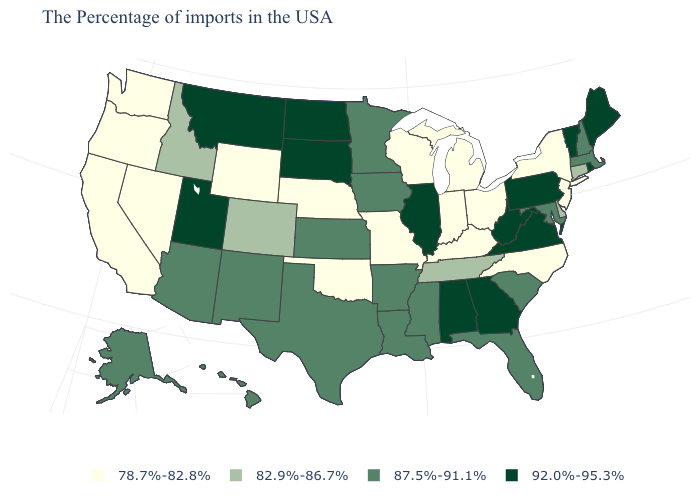What is the value of North Dakota?
Keep it brief. 92.0%-95.3%. What is the highest value in the USA?
Be succinct. 92.0%-95.3%. Does the first symbol in the legend represent the smallest category?
Give a very brief answer. Yes. Among the states that border Rhode Island , which have the highest value?
Keep it brief. Massachusetts. Among the states that border Rhode Island , which have the lowest value?
Answer briefly. Connecticut. What is the highest value in states that border Ohio?
Write a very short answer. 92.0%-95.3%. What is the lowest value in the MidWest?
Write a very short answer. 78.7%-82.8%. Name the states that have a value in the range 78.7%-82.8%?
Answer briefly. New York, New Jersey, North Carolina, Ohio, Michigan, Kentucky, Indiana, Wisconsin, Missouri, Nebraska, Oklahoma, Wyoming, Nevada, California, Washington, Oregon. Which states have the highest value in the USA?
Concise answer only. Maine, Rhode Island, Vermont, Pennsylvania, Virginia, West Virginia, Georgia, Alabama, Illinois, South Dakota, North Dakota, Utah, Montana. What is the value of Delaware?
Concise answer only. 82.9%-86.7%. Among the states that border Maryland , does Virginia have the highest value?
Concise answer only. Yes. How many symbols are there in the legend?
Keep it brief. 4. Which states have the lowest value in the USA?
Answer briefly. New York, New Jersey, North Carolina, Ohio, Michigan, Kentucky, Indiana, Wisconsin, Missouri, Nebraska, Oklahoma, Wyoming, Nevada, California, Washington, Oregon. Name the states that have a value in the range 82.9%-86.7%?
Concise answer only. Connecticut, Delaware, Tennessee, Colorado, Idaho. What is the lowest value in the USA?
Answer briefly. 78.7%-82.8%. 